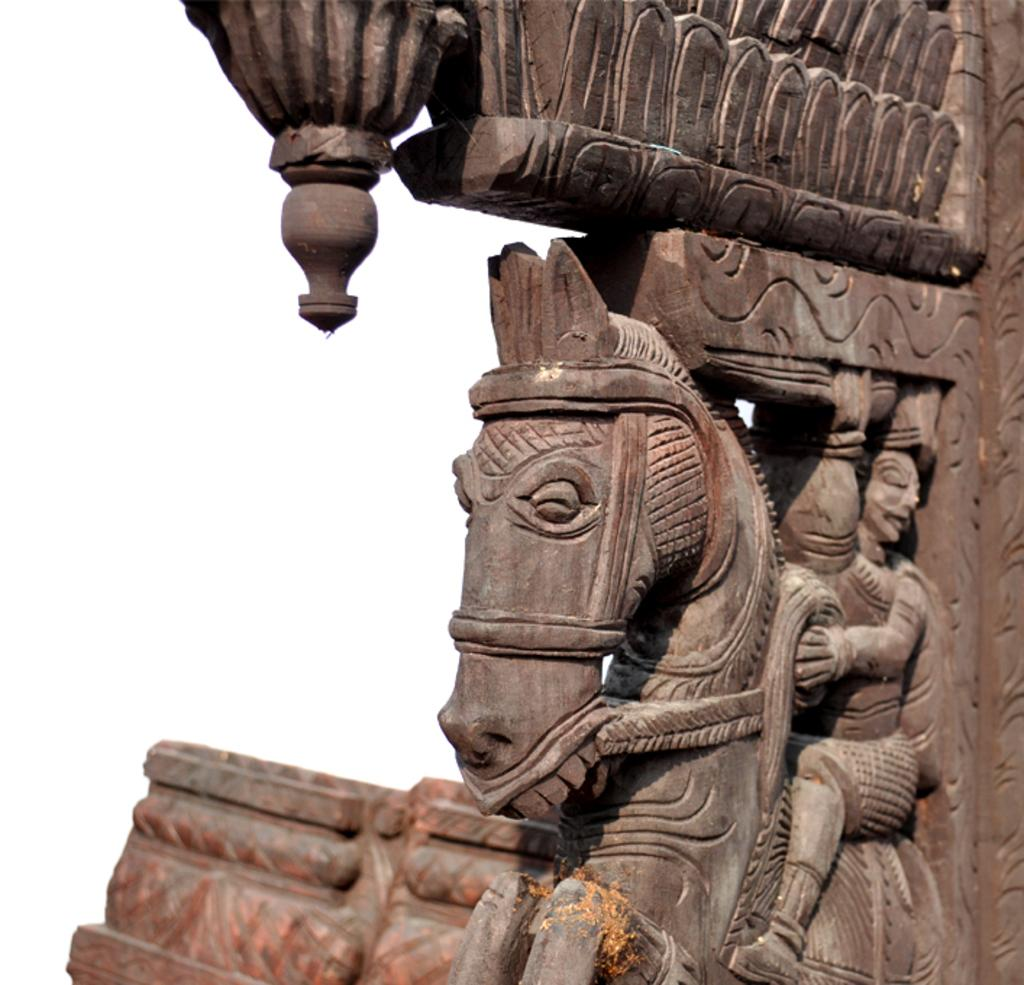What type of object can be seen in the image with carvings on it? There is a wooden object with carvings in the image. What color is the background of the image? The background of the image is white. What type of fuel is being used by the bikes in the image? There are no bikes present in the image, so it is not possible to determine what type of fuel they might be using. 